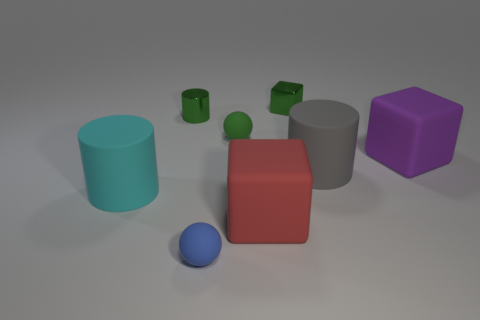Subtract all small green metal cylinders. How many cylinders are left? 2 Subtract all cubes. How many objects are left? 5 Subtract 3 cylinders. How many cylinders are left? 0 Subtract all gray cylinders. How many cylinders are left? 2 Subtract 1 green cylinders. How many objects are left? 7 Subtract all blue balls. Subtract all gray cylinders. How many balls are left? 1 Subtract all blue spheres. How many cyan cylinders are left? 1 Subtract all cyan objects. Subtract all gray rubber things. How many objects are left? 6 Add 5 big gray things. How many big gray things are left? 6 Add 3 shiny balls. How many shiny balls exist? 3 